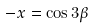Convert formula to latex. <formula><loc_0><loc_0><loc_500><loc_500>- x = \cos 3 \beta</formula> 